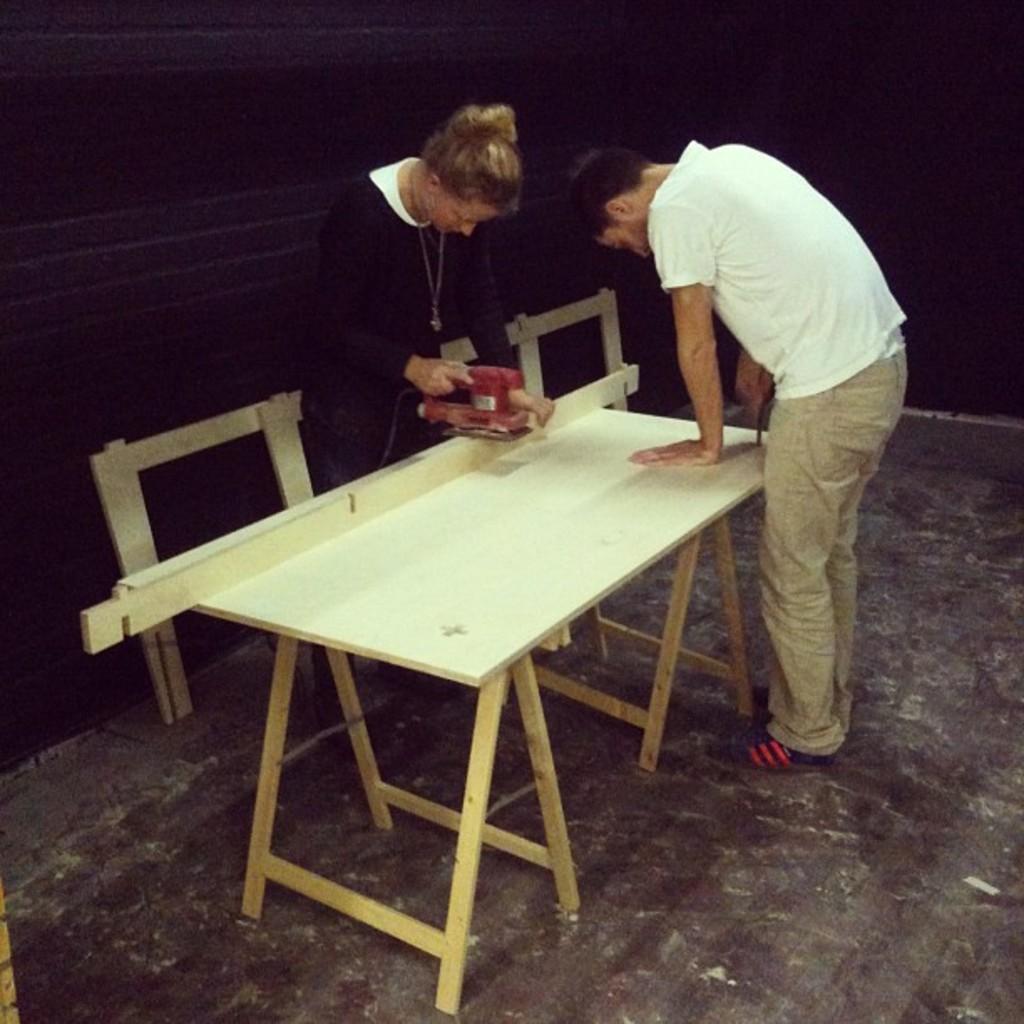How would you summarize this image in a sentence or two? A lady with black color dress is stunning. And cutting the wood with cutting machine. In front of her there is a man with white color t-shirt is standing. There is a table. 